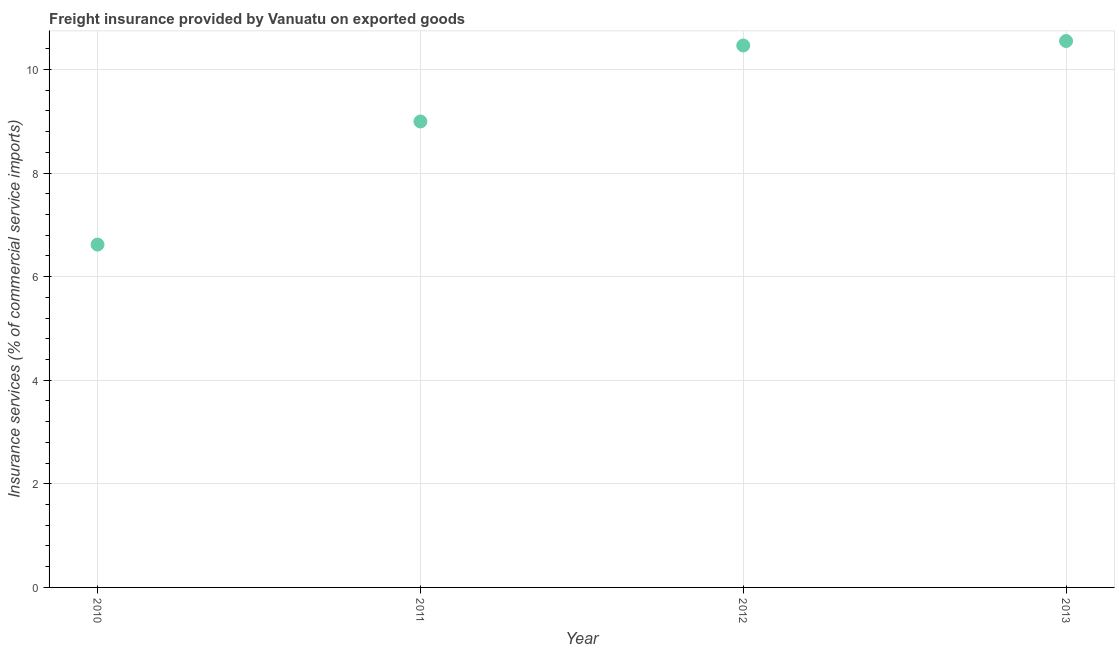What is the freight insurance in 2011?
Your answer should be very brief. 9. Across all years, what is the maximum freight insurance?
Provide a succinct answer. 10.55. Across all years, what is the minimum freight insurance?
Offer a terse response. 6.62. In which year was the freight insurance maximum?
Keep it short and to the point. 2013. What is the sum of the freight insurance?
Ensure brevity in your answer.  36.63. What is the difference between the freight insurance in 2011 and 2012?
Make the answer very short. -1.47. What is the average freight insurance per year?
Your answer should be very brief. 9.16. What is the median freight insurance?
Provide a short and direct response. 9.73. In how many years, is the freight insurance greater than 0.4 %?
Ensure brevity in your answer.  4. Do a majority of the years between 2010 and 2012 (inclusive) have freight insurance greater than 2 %?
Offer a terse response. Yes. What is the ratio of the freight insurance in 2011 to that in 2012?
Your answer should be compact. 0.86. Is the freight insurance in 2010 less than that in 2013?
Offer a very short reply. Yes. Is the difference between the freight insurance in 2010 and 2013 greater than the difference between any two years?
Make the answer very short. Yes. What is the difference between the highest and the second highest freight insurance?
Offer a terse response. 0.09. What is the difference between the highest and the lowest freight insurance?
Your answer should be very brief. 3.93. How many years are there in the graph?
Provide a succinct answer. 4. What is the difference between two consecutive major ticks on the Y-axis?
Keep it short and to the point. 2. Are the values on the major ticks of Y-axis written in scientific E-notation?
Make the answer very short. No. Does the graph contain any zero values?
Offer a terse response. No. What is the title of the graph?
Offer a terse response. Freight insurance provided by Vanuatu on exported goods . What is the label or title of the X-axis?
Provide a short and direct response. Year. What is the label or title of the Y-axis?
Provide a short and direct response. Insurance services (% of commercial service imports). What is the Insurance services (% of commercial service imports) in 2010?
Give a very brief answer. 6.62. What is the Insurance services (% of commercial service imports) in 2011?
Offer a terse response. 9. What is the Insurance services (% of commercial service imports) in 2012?
Offer a terse response. 10.46. What is the Insurance services (% of commercial service imports) in 2013?
Offer a very short reply. 10.55. What is the difference between the Insurance services (% of commercial service imports) in 2010 and 2011?
Provide a succinct answer. -2.38. What is the difference between the Insurance services (% of commercial service imports) in 2010 and 2012?
Keep it short and to the point. -3.84. What is the difference between the Insurance services (% of commercial service imports) in 2010 and 2013?
Give a very brief answer. -3.93. What is the difference between the Insurance services (% of commercial service imports) in 2011 and 2012?
Your answer should be compact. -1.47. What is the difference between the Insurance services (% of commercial service imports) in 2011 and 2013?
Your response must be concise. -1.55. What is the difference between the Insurance services (% of commercial service imports) in 2012 and 2013?
Keep it short and to the point. -0.09. What is the ratio of the Insurance services (% of commercial service imports) in 2010 to that in 2011?
Keep it short and to the point. 0.74. What is the ratio of the Insurance services (% of commercial service imports) in 2010 to that in 2012?
Keep it short and to the point. 0.63. What is the ratio of the Insurance services (% of commercial service imports) in 2010 to that in 2013?
Make the answer very short. 0.63. What is the ratio of the Insurance services (% of commercial service imports) in 2011 to that in 2012?
Make the answer very short. 0.86. What is the ratio of the Insurance services (% of commercial service imports) in 2011 to that in 2013?
Give a very brief answer. 0.85. 